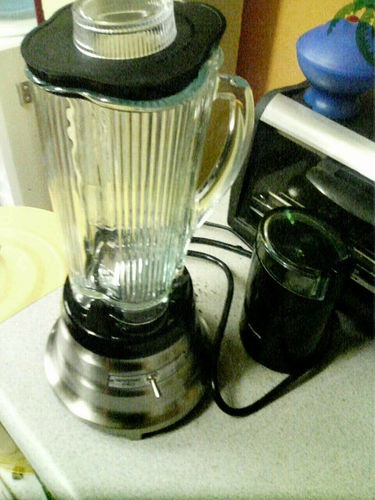Describe the objects in this image and their specific colors. I can see various objects in this image with different colors. 